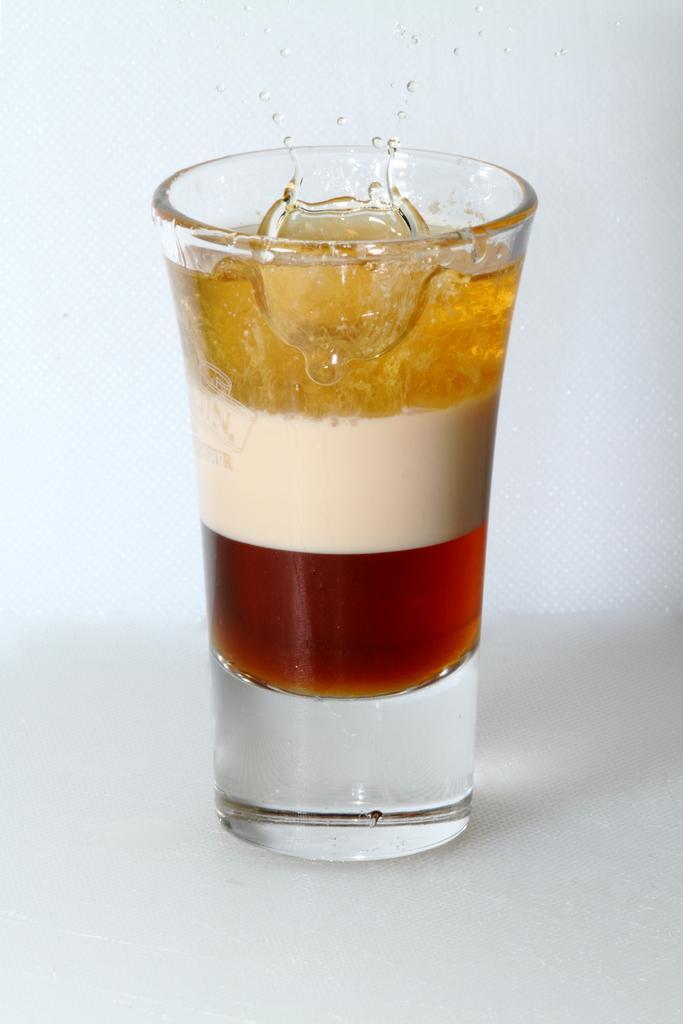Describe this image in one or two sentences. In this image we can see a glass containing three color liquids in it. 